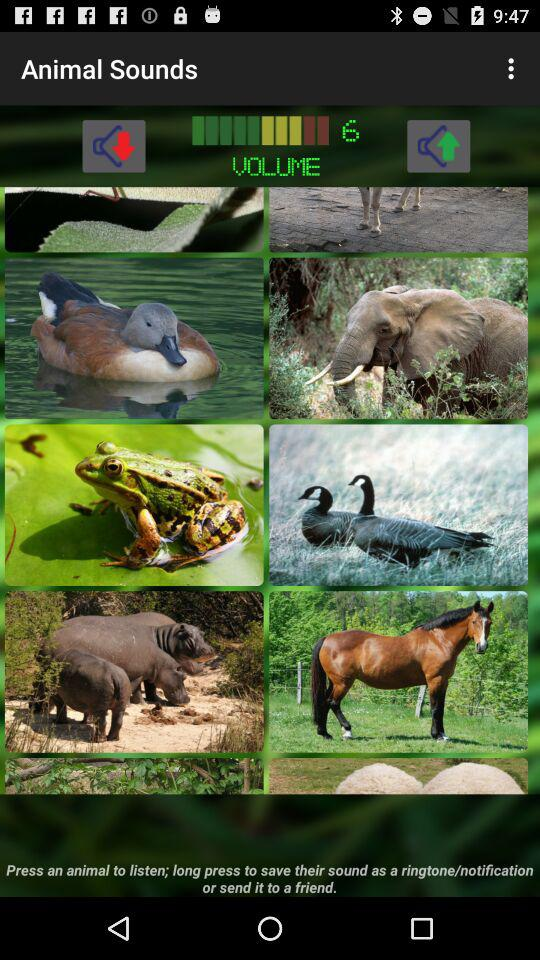What is the selected volume? The selected volume is 6. 